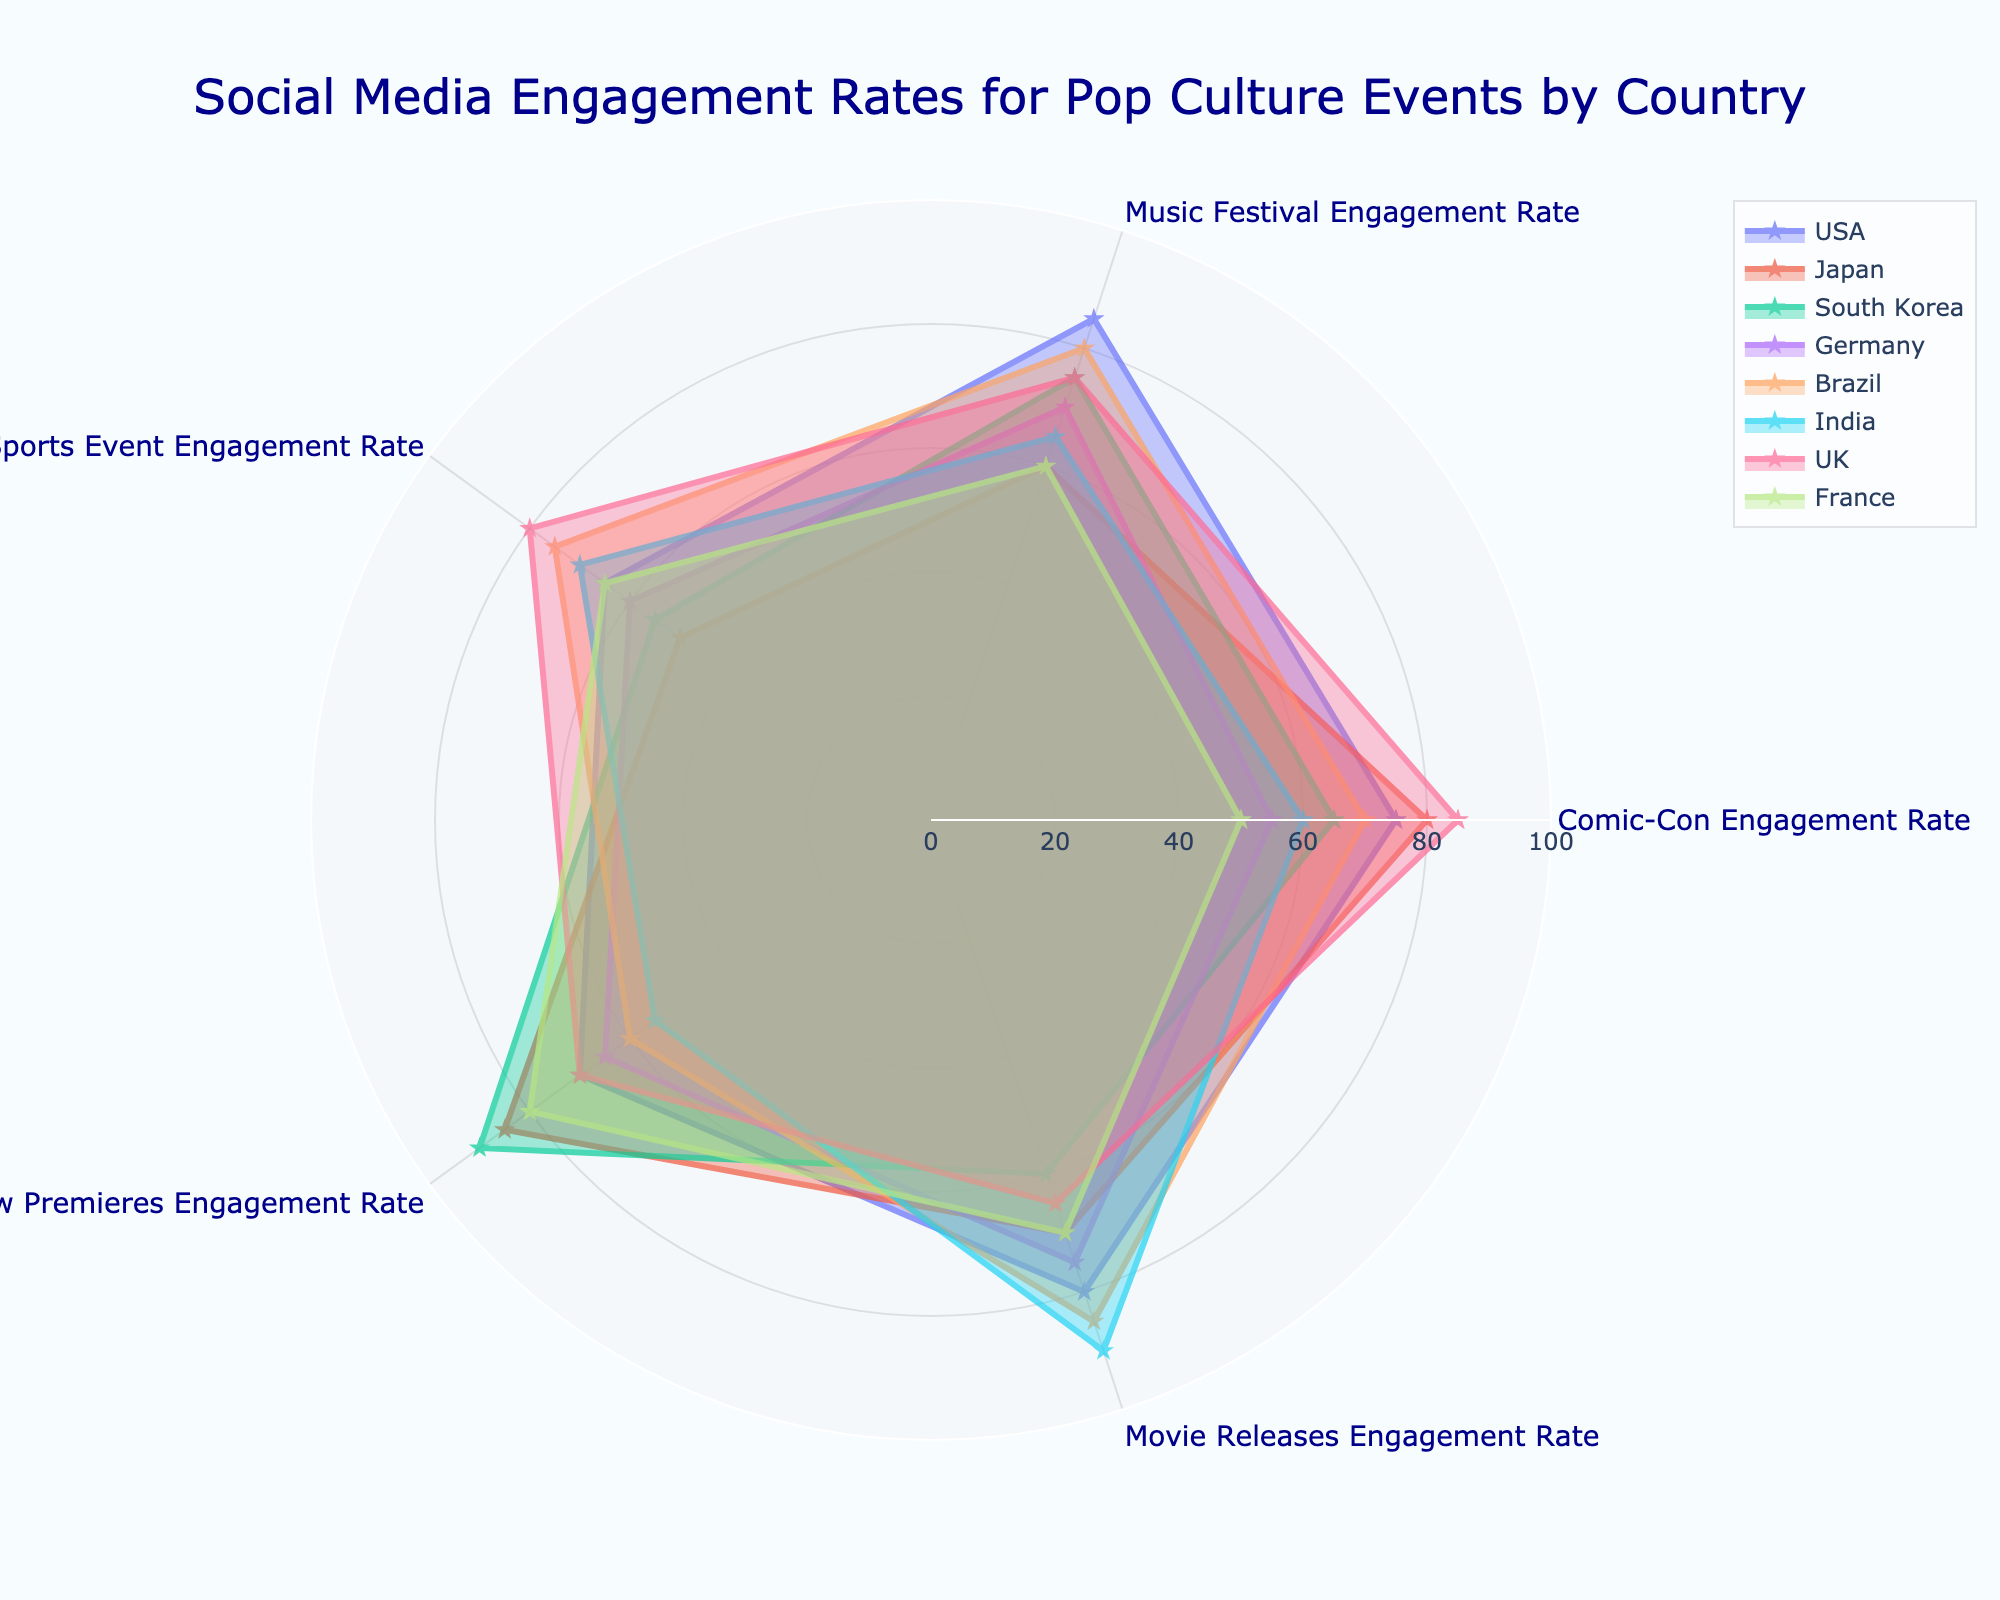What's the title of the plot? The title is usually prominently displayed at the top of the figure. Based on the provided code, the title of the plot is "Social Media Engagement Rates for Pop Culture Events by Country".
Answer: Social Media Engagement Rates for Pop Culture Events by Country Which country has the highest engagement rate for TV Show Premieres? To find this, look at the TV Show Premieres section of the radar chart and identify the country with the highest value. South Korea has the highest engagement rate for TV Show Premieres at 90%.
Answer: South Korea Which country has the lowest engagement rate for Movie Releases? Look for the Movie Releases data points on the radar chart and identify the country with the lowest value. South Korea has the lowest engagement rate for Movie Releases at 60%.
Answer: South Korea What is the range of engagement rates shown on the chart? The range refers to the difference between the maximum and minimum values displayed. The minimum engagement rate is 50%, and the maximum is 90%. Therefore, the range is 90% - 50% = 40%.
Answer: 40% Compare the engagement rates for Sports Events between the USA and Brazil. Look at the Sports Event Engagement Rate for both the USA and Brazil on the radar chart. The USA has a rate of 65%, while Brazil has a rate of 75%.
Answer: Brazil has a higher rate than the USA What is the average engagement rate for Comic-Con across all the countries? To find this, sum the Comic-Con engagement rates for all eight countries and then divide by the number of countries. (75 + 80 + 65 + 55 + 70 + 60 + 85 + 50) / 8 = 67.5%
Answer: 67.5% Which country shows the most similar engagement rates across all pop culture events? Look for a country whose radar chart shape appears almost like a regular polygon, indicating similar engagement rates across all categories. The UK shows the most consistent engagement rates across all events.
Answer: UK By how much does Japan's engagement rate for TV Show Premieres exceed Germany's rate for the same event? Look for the TV Show Premieres rates for Japan and Germany. Japan's rate is 85%, and Germany's rate is 65%. The difference is 85% - 65% = 20%.
Answer: 20% Which two countries have the most balanced engagement rates, with no extreme highs or lows? Look for countries whose radar chart shapes are more regular and less spiked. France and Germany have relatively balanced engagement rates without extreme highs or lows.
Answer: France and Germany Identify the country with the lowest engagement rate for Music Festivals and indicate how much lower it is than the highest rate for the same event. Look for Music Festival rates: the lowest is France at 60% and the highest is the USA at 85%. The difference is 85% - 60% = 25%.
Answer: France, 25% 